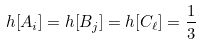Convert formula to latex. <formula><loc_0><loc_0><loc_500><loc_500>h [ A _ { i } ] = h [ B _ { j } ] = h [ C _ { \ell } ] = \frac { 1 } { 3 }</formula> 